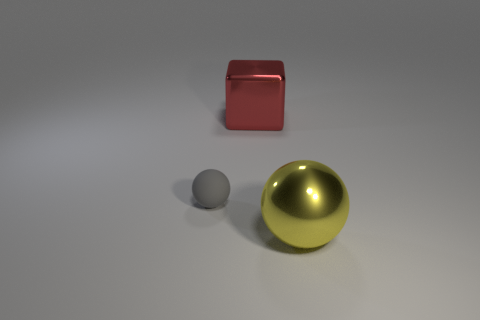What shape is the yellow metal object?
Offer a terse response. Sphere. There is a sphere to the right of the shiny object to the left of the large thing that is in front of the metallic block; what is its size?
Offer a very short reply. Large. How many other objects are there of the same shape as the large yellow object?
Your answer should be very brief. 1. Is the shape of the large thing to the right of the large metal block the same as the object that is on the left side of the red metallic cube?
Provide a succinct answer. Yes. What number of blocks are small gray things or metal things?
Your answer should be very brief. 1. The big thing that is behind the sphere that is on the right side of the shiny object behind the small matte sphere is made of what material?
Offer a very short reply. Metal. What number of other things are there of the same size as the yellow shiny sphere?
Give a very brief answer. 1. Are there more big red cubes behind the tiny gray matte object than cyan cylinders?
Offer a very short reply. Yes. Are there any big metal things of the same color as the large cube?
Ensure brevity in your answer.  No. There is a thing that is the same size as the shiny ball; what is its color?
Provide a short and direct response. Red. 